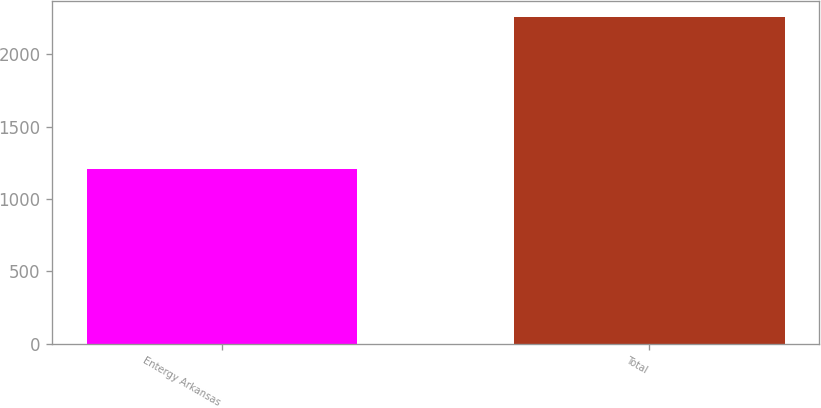<chart> <loc_0><loc_0><loc_500><loc_500><bar_chart><fcel>Entergy Arkansas<fcel>Total<nl><fcel>1207<fcel>2259<nl></chart> 